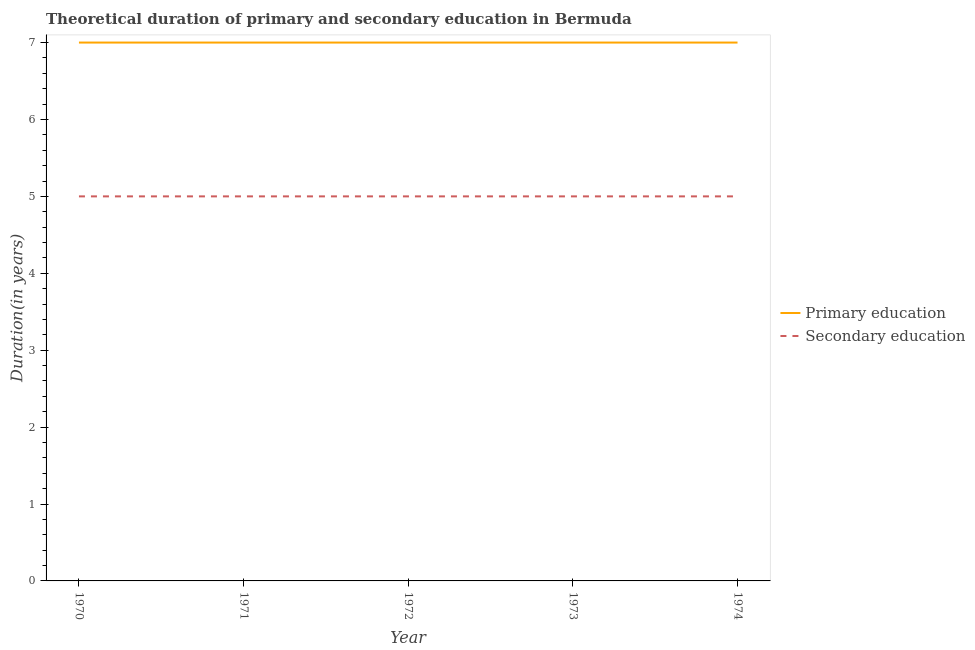How many different coloured lines are there?
Offer a very short reply. 2. What is the duration of secondary education in 1972?
Keep it short and to the point. 5. Across all years, what is the maximum duration of primary education?
Provide a succinct answer. 7. Across all years, what is the minimum duration of secondary education?
Your answer should be compact. 5. In which year was the duration of primary education maximum?
Your answer should be compact. 1970. In which year was the duration of secondary education minimum?
Provide a succinct answer. 1970. What is the total duration of primary education in the graph?
Provide a succinct answer. 35. What is the difference between the duration of secondary education in 1973 and that in 1974?
Make the answer very short. 0. What is the difference between the duration of secondary education in 1970 and the duration of primary education in 1973?
Give a very brief answer. -2. In the year 1970, what is the difference between the duration of primary education and duration of secondary education?
Your answer should be very brief. 2. What is the ratio of the duration of secondary education in 1971 to that in 1974?
Offer a very short reply. 1. Is the difference between the duration of secondary education in 1972 and 1974 greater than the difference between the duration of primary education in 1972 and 1974?
Offer a terse response. No. What is the difference between the highest and the second highest duration of secondary education?
Make the answer very short. 0. In how many years, is the duration of primary education greater than the average duration of primary education taken over all years?
Offer a terse response. 0. Does the duration of secondary education monotonically increase over the years?
Keep it short and to the point. No. Is the duration of primary education strictly greater than the duration of secondary education over the years?
Offer a terse response. Yes. How many lines are there?
Your response must be concise. 2. What is the difference between two consecutive major ticks on the Y-axis?
Ensure brevity in your answer.  1. Are the values on the major ticks of Y-axis written in scientific E-notation?
Give a very brief answer. No. Does the graph contain any zero values?
Provide a short and direct response. No. Does the graph contain grids?
Give a very brief answer. No. What is the title of the graph?
Your answer should be compact. Theoretical duration of primary and secondary education in Bermuda. Does "Investment" appear as one of the legend labels in the graph?
Keep it short and to the point. No. What is the label or title of the Y-axis?
Keep it short and to the point. Duration(in years). What is the Duration(in years) in Secondary education in 1970?
Give a very brief answer. 5. What is the Duration(in years) in Secondary education in 1971?
Provide a succinct answer. 5. What is the Duration(in years) of Primary education in 1972?
Offer a very short reply. 7. What is the Duration(in years) of Secondary education in 1972?
Offer a terse response. 5. What is the Duration(in years) of Primary education in 1973?
Keep it short and to the point. 7. Across all years, what is the maximum Duration(in years) of Secondary education?
Provide a succinct answer. 5. What is the difference between the Duration(in years) in Primary education in 1970 and that in 1971?
Ensure brevity in your answer.  0. What is the difference between the Duration(in years) of Secondary education in 1970 and that in 1972?
Keep it short and to the point. 0. What is the difference between the Duration(in years) of Secondary education in 1970 and that in 1973?
Make the answer very short. 0. What is the difference between the Duration(in years) of Secondary education in 1970 and that in 1974?
Give a very brief answer. 0. What is the difference between the Duration(in years) in Primary education in 1971 and that in 1972?
Your response must be concise. 0. What is the difference between the Duration(in years) of Secondary education in 1971 and that in 1972?
Give a very brief answer. 0. What is the difference between the Duration(in years) in Primary education in 1971 and that in 1973?
Give a very brief answer. 0. What is the difference between the Duration(in years) in Secondary education in 1971 and that in 1973?
Your answer should be compact. 0. What is the difference between the Duration(in years) in Primary education in 1972 and that in 1974?
Give a very brief answer. 0. What is the difference between the Duration(in years) in Primary education in 1973 and that in 1974?
Give a very brief answer. 0. What is the difference between the Duration(in years) of Secondary education in 1973 and that in 1974?
Provide a short and direct response. 0. What is the difference between the Duration(in years) of Primary education in 1970 and the Duration(in years) of Secondary education in 1971?
Ensure brevity in your answer.  2. What is the difference between the Duration(in years) in Primary education in 1970 and the Duration(in years) in Secondary education in 1973?
Provide a succinct answer. 2. What is the difference between the Duration(in years) in Primary education in 1971 and the Duration(in years) in Secondary education in 1972?
Make the answer very short. 2. What is the difference between the Duration(in years) of Primary education in 1971 and the Duration(in years) of Secondary education in 1974?
Give a very brief answer. 2. What is the difference between the Duration(in years) in Primary education in 1972 and the Duration(in years) in Secondary education in 1973?
Your answer should be very brief. 2. What is the difference between the Duration(in years) of Primary education in 1973 and the Duration(in years) of Secondary education in 1974?
Keep it short and to the point. 2. What is the average Duration(in years) in Secondary education per year?
Give a very brief answer. 5. In the year 1970, what is the difference between the Duration(in years) of Primary education and Duration(in years) of Secondary education?
Keep it short and to the point. 2. In the year 1972, what is the difference between the Duration(in years) of Primary education and Duration(in years) of Secondary education?
Your response must be concise. 2. In the year 1973, what is the difference between the Duration(in years) of Primary education and Duration(in years) of Secondary education?
Provide a short and direct response. 2. What is the ratio of the Duration(in years) of Primary education in 1970 to that in 1971?
Ensure brevity in your answer.  1. What is the ratio of the Duration(in years) in Primary education in 1970 to that in 1972?
Keep it short and to the point. 1. What is the ratio of the Duration(in years) in Secondary education in 1970 to that in 1972?
Your answer should be compact. 1. What is the ratio of the Duration(in years) of Primary education in 1970 to that in 1973?
Your answer should be compact. 1. What is the ratio of the Duration(in years) of Secondary education in 1970 to that in 1974?
Make the answer very short. 1. What is the ratio of the Duration(in years) of Primary education in 1971 to that in 1972?
Give a very brief answer. 1. What is the ratio of the Duration(in years) in Primary education in 1971 to that in 1973?
Offer a terse response. 1. What is the ratio of the Duration(in years) in Secondary education in 1971 to that in 1973?
Your response must be concise. 1. What is the ratio of the Duration(in years) of Primary education in 1971 to that in 1974?
Your answer should be compact. 1. What is the ratio of the Duration(in years) of Secondary education in 1971 to that in 1974?
Offer a very short reply. 1. What is the ratio of the Duration(in years) in Secondary education in 1972 to that in 1973?
Offer a very short reply. 1. What is the ratio of the Duration(in years) of Primary education in 1972 to that in 1974?
Make the answer very short. 1. What is the ratio of the Duration(in years) of Primary education in 1973 to that in 1974?
Keep it short and to the point. 1. What is the difference between the highest and the second highest Duration(in years) of Primary education?
Keep it short and to the point. 0. What is the difference between the highest and the lowest Duration(in years) in Secondary education?
Offer a very short reply. 0. 